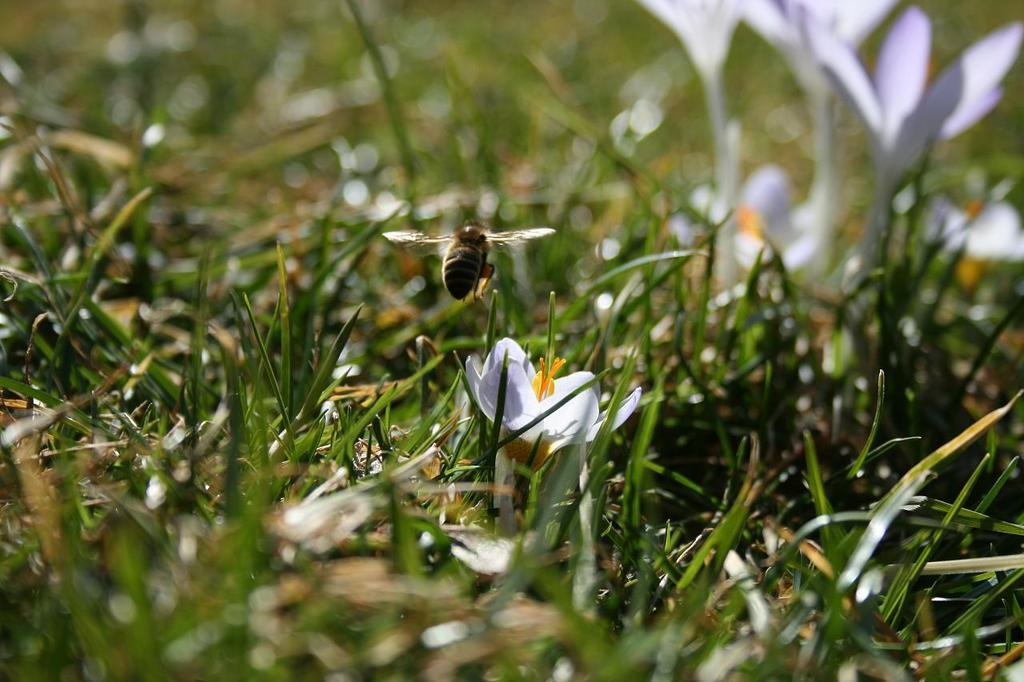What type of vegetation is present in the image? There is green grass in the image. What other natural elements can be seen in the image? There are flowers in the image. Can you describe any living creatures in the image? There is a honey bee in the air in the image. What type of jeans is the father wearing in the image? There is no father or jeans present in the image. How many kittens can be seen playing with the flowers in the image? There are no kittens present in the image; it features green grass, flowers, and a honey bee. 